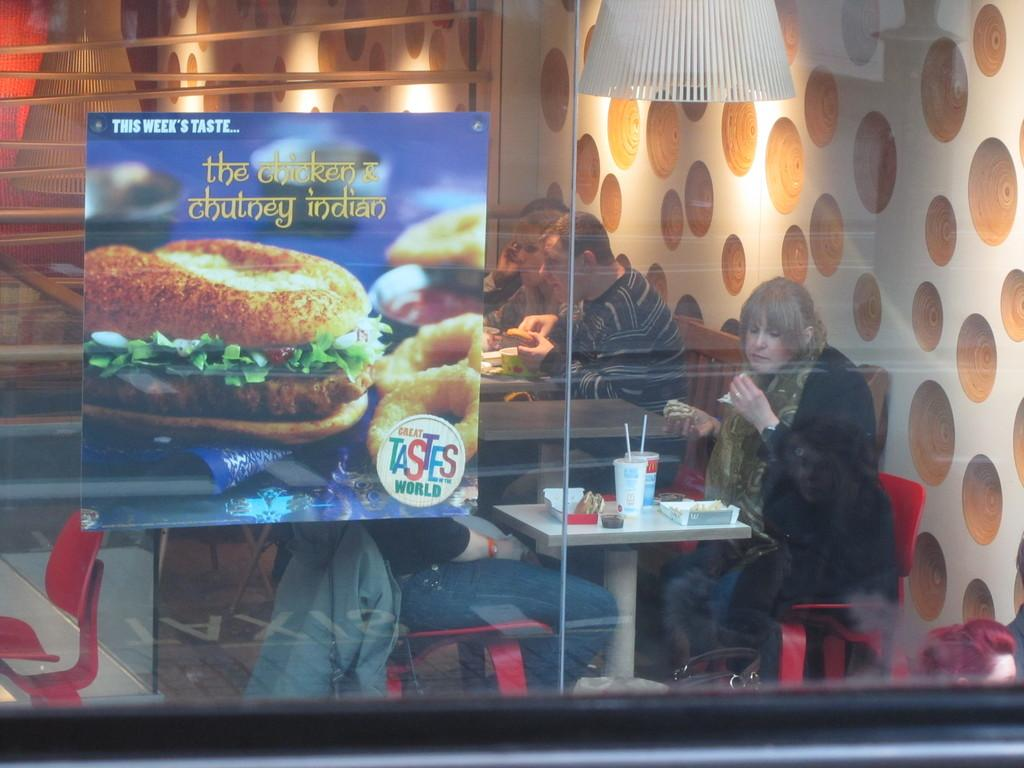What is covering the glass in the image? There is a poster over a glass in the image. What are the persons in the image doing? The persons are sitting on chairs in front of a table and having food. What can be found on the table besides the food? There are boxes and glasses with straws on the table. How many books are visible on the table in the image? There are no books visible on the table in the image. Are there any women present in the image? The provided facts do not mention any women in the image. 